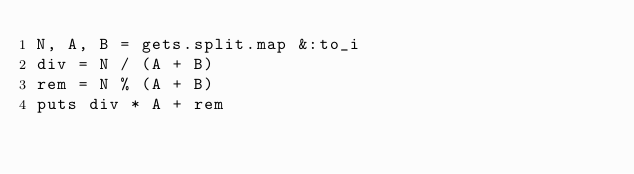<code> <loc_0><loc_0><loc_500><loc_500><_Ruby_>N, A, B = gets.split.map &:to_i
div = N / (A + B)
rem = N % (A + B)
puts div * A + rem</code> 